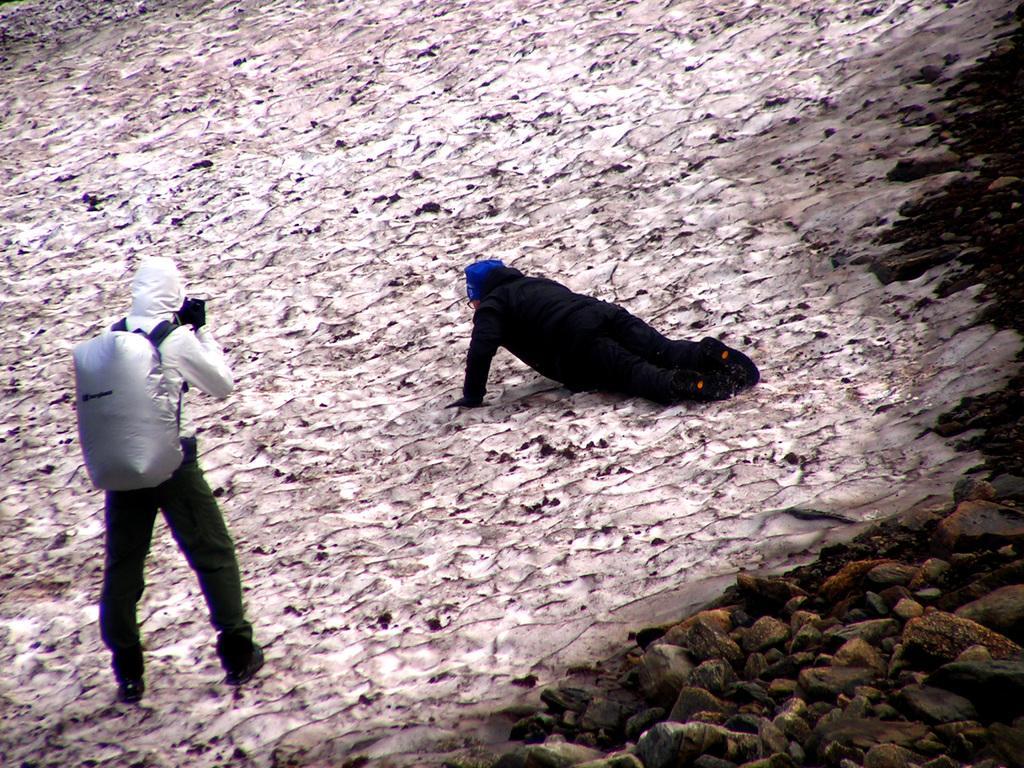Could you give a brief overview of what you see in this image? This picture describes about few people, on the left side of the image we can see a person, and the person wore a bag, beside to them we can see few rocks. 